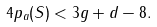<formula> <loc_0><loc_0><loc_500><loc_500>4 p _ { a } ( S ) < 3 g + d - 8 .</formula> 